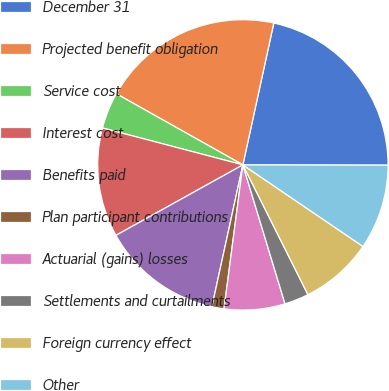Convert chart to OTSL. <chart><loc_0><loc_0><loc_500><loc_500><pie_chart><fcel>December 31<fcel>Projected benefit obligation<fcel>Service cost<fcel>Interest cost<fcel>Benefits paid<fcel>Plan participant contributions<fcel>Actuarial (gains) losses<fcel>Settlements and curtailments<fcel>Foreign currency effect<fcel>Other<nl><fcel>21.62%<fcel>20.27%<fcel>4.06%<fcel>12.16%<fcel>13.51%<fcel>1.35%<fcel>6.76%<fcel>2.71%<fcel>8.11%<fcel>9.46%<nl></chart> 